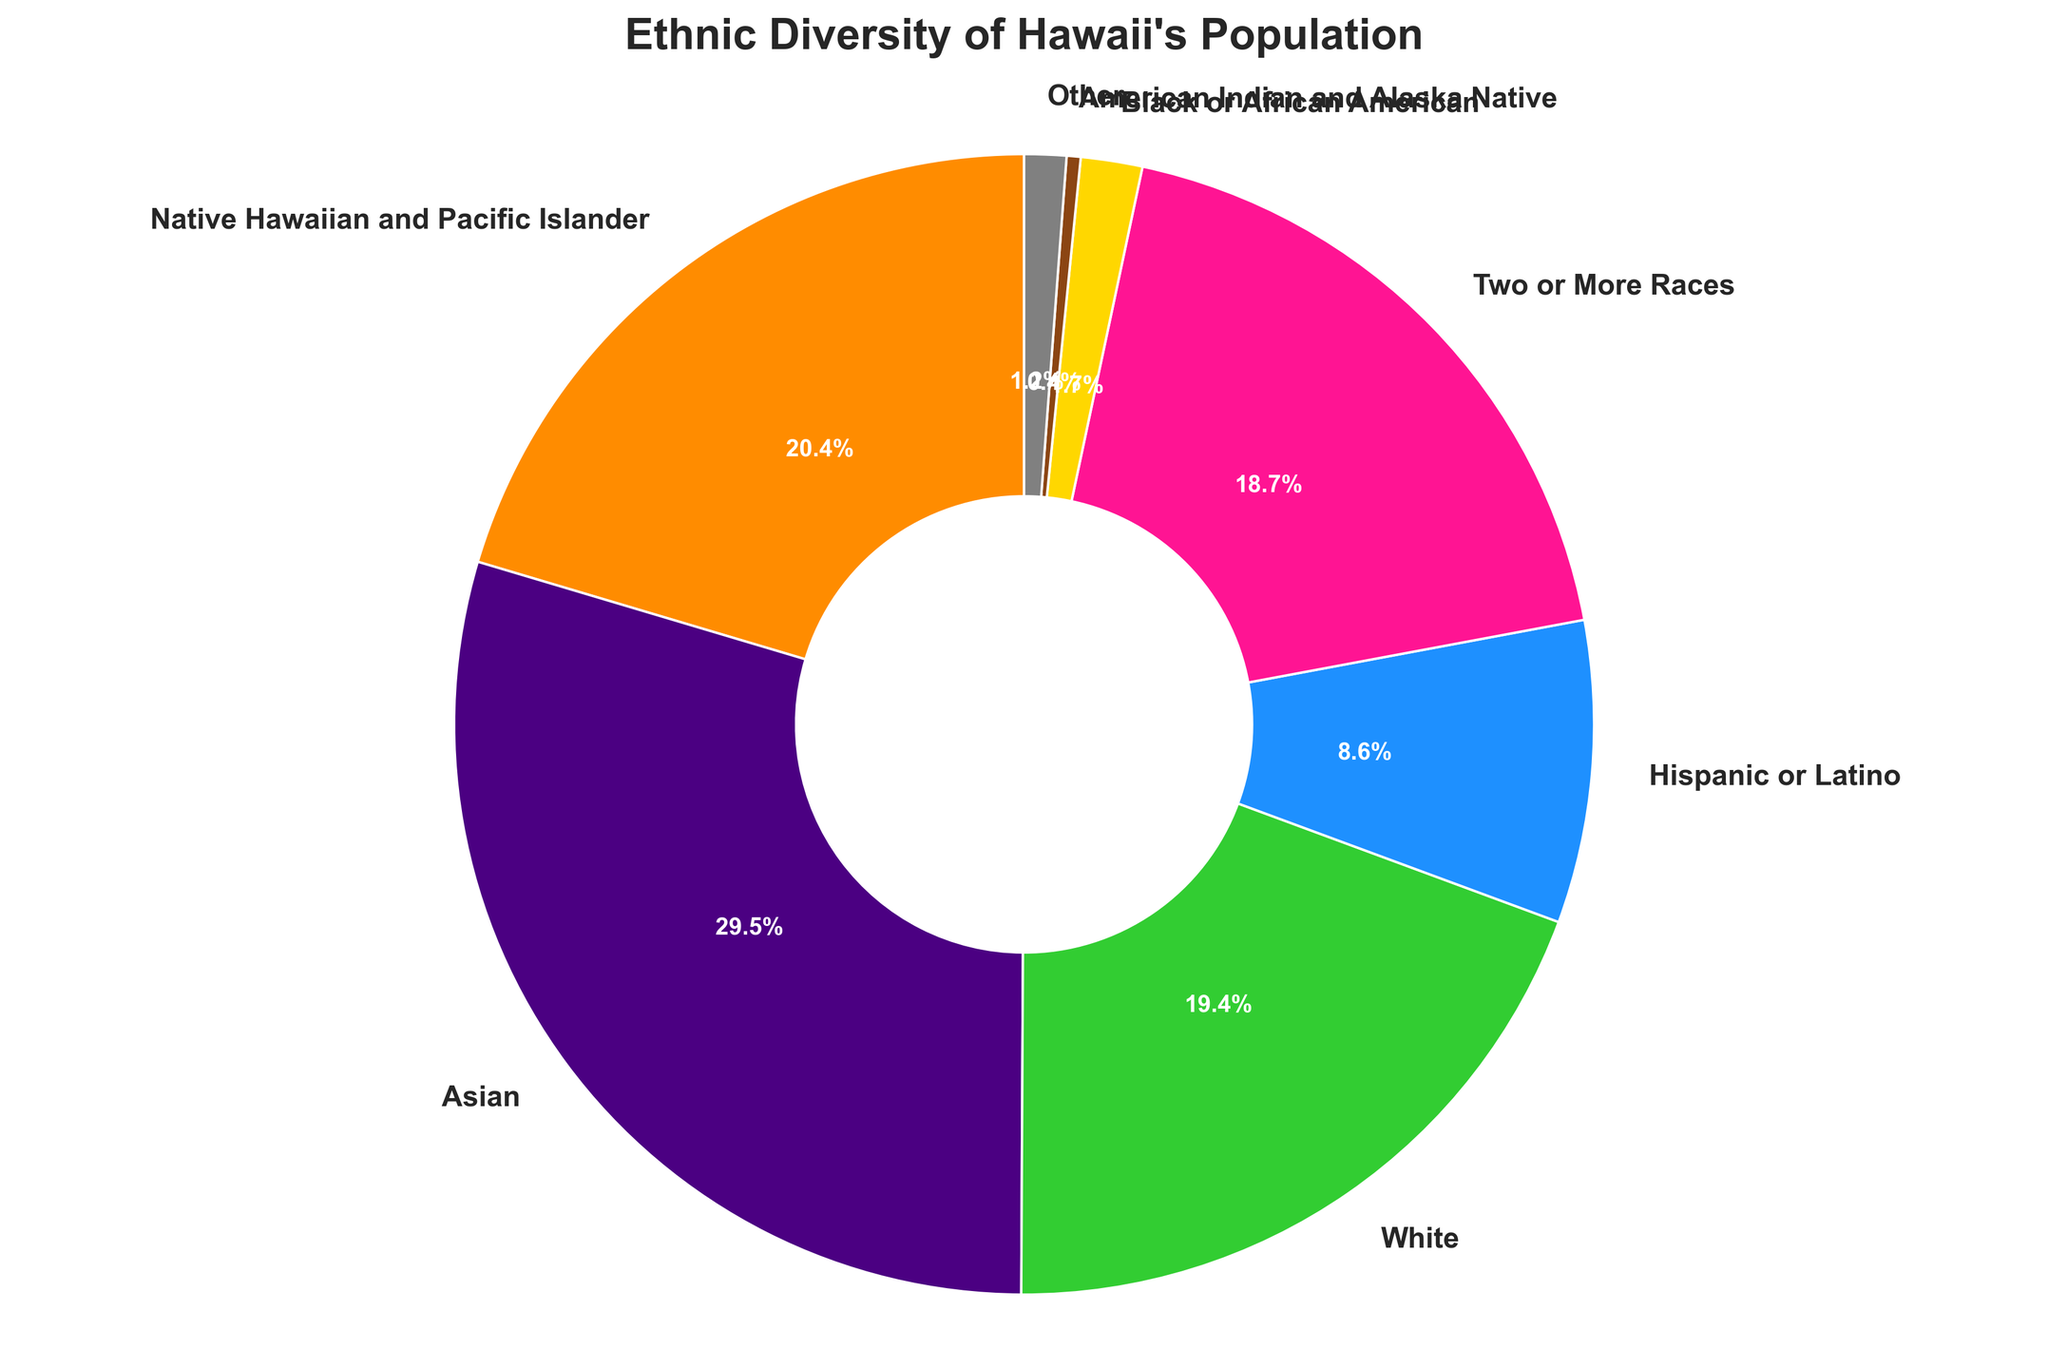Which ethnicity represents the largest percentage of Hawaii’s population? By looking at the pie chart, the largest wedge corresponds to the "Asian" category.
Answer: Asian Which ethnicities combined have a greater percentage than "White"? The sum of "Native Hawaiian and Pacific Islander" and "Two or More Races" exceeds "White".
Answer: Native Hawaiian and Pacific Islander, Two or More Races What is the difference in percentage between the "White" and "Hispanic or Latino" populations? The "White" population is 24.5%, and the "Hispanic or Latino" population is 10.8%. The difference is 24.5 - 10.8 = 13.7%.
Answer: 13.7% How much larger is the "Asian" population compared to the "Black or African American" population? The "Asian" population is 37.2%, and the "Black or African American" population is 2.2%. The difference is 37.2 - 2.2 = 35%.
Answer: 35% Which ethnic group is represented by the green section in the chart? The green section corresponds to the "White" category.
Answer: White What is the total percentage of the "White" and "Asian" populations combined? The percentage for "White" is 24.5%, and for "Asian", it is 37.2%. Adding these gives 24.5 + 37.2 = 61.7%.
Answer: 61.7% Which ethnicity has a marginally greater percentage than "White"? The "Native Hawaiian and Pacific Islander" population, with 25.7%, is slightly higher than the "White" population.
Answer: Native Hawaiian and Pacific Islander Out of the ethnicities shown, which has the smallest representation? The "American Indian and Alaska Native" population, at 0.5%, is the smallest.
Answer: American Indian and Alaska Native 